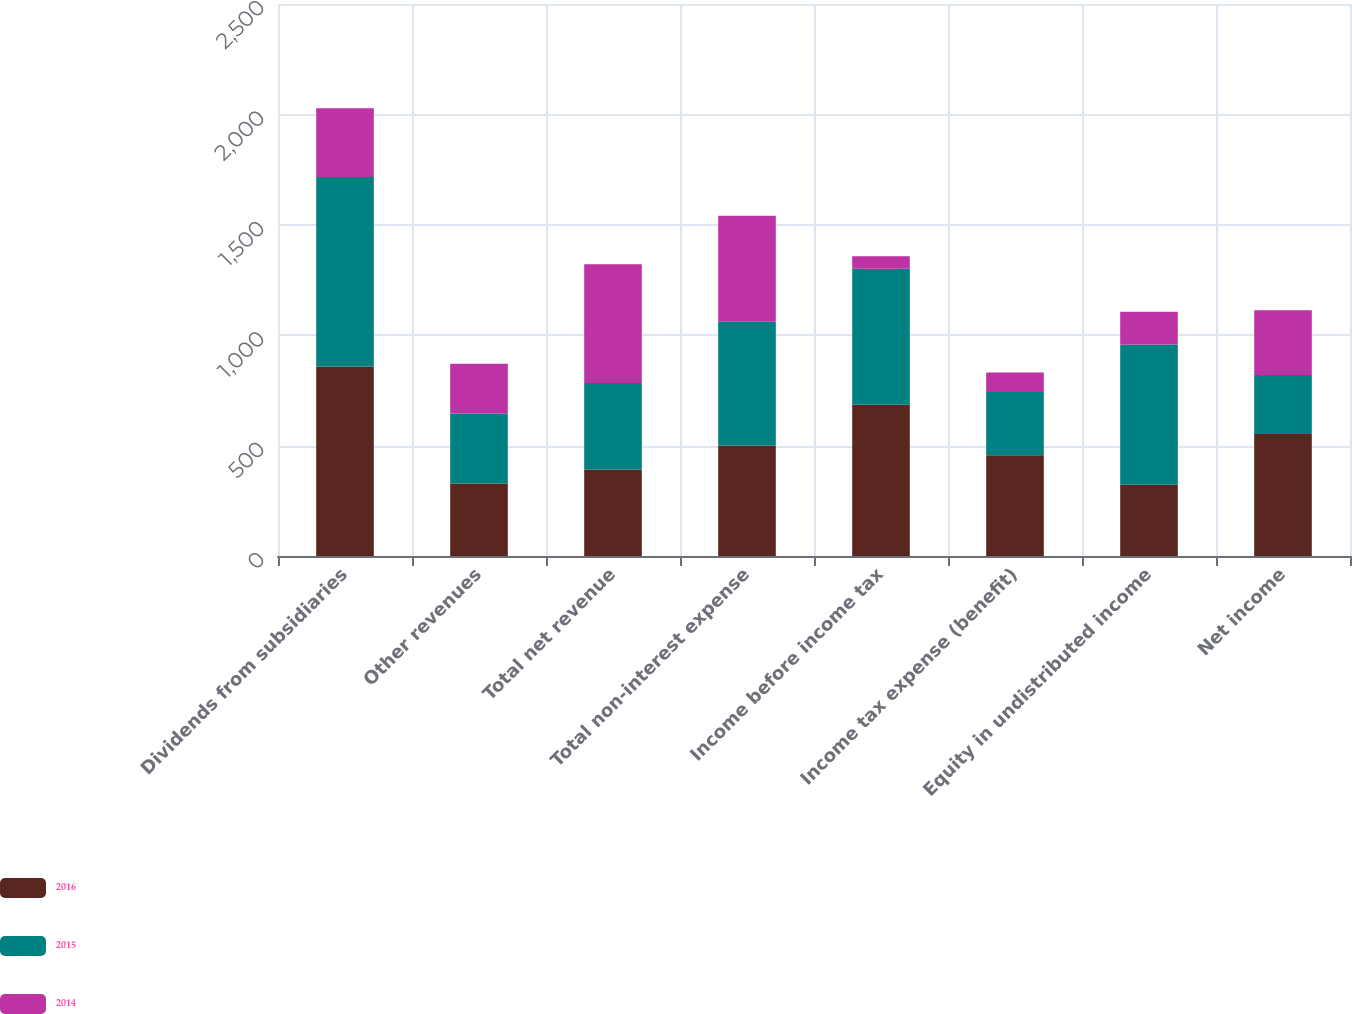Convert chart. <chart><loc_0><loc_0><loc_500><loc_500><stacked_bar_chart><ecel><fcel>Dividends from subsidiaries<fcel>Other revenues<fcel>Total net revenue<fcel>Total non-interest expense<fcel>Income before income tax<fcel>Income tax expense (benefit)<fcel>Equity in undistributed income<fcel>Net income<nl><fcel>2016<fcel>858<fcel>328<fcel>392<fcel>501<fcel>685<fcel>456<fcel>323<fcel>552<nl><fcel>2015<fcel>859<fcel>317<fcel>392<fcel>560<fcel>616<fcel>287<fcel>635<fcel>268<nl><fcel>2014<fcel>311<fcel>226<fcel>537<fcel>480<fcel>57<fcel>88<fcel>148<fcel>293<nl></chart> 